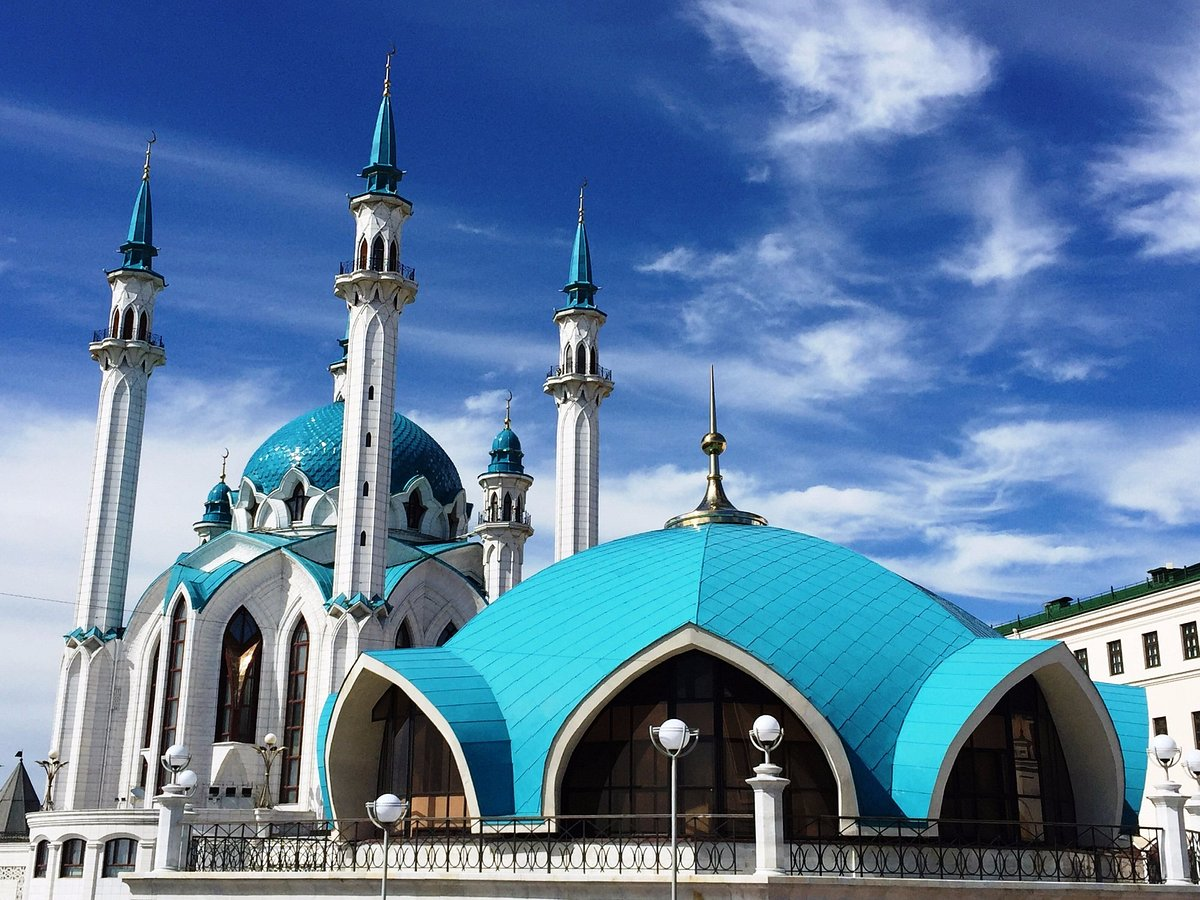Analyze the image in a comprehensive and detailed manner. The image showcases the Qolşärif Mosque located within the Kazan Kremlin, in Kazan, Russia. This mosque, characterized by its vibrant blue and white facade, features four slender minarets and a large central dome, reflecting the Tatar architectural style. The mosque is not only a religious site but also a symbol of Tatar national pride and cultural identity. Its reconstruction was completed in 2005, originally being built in the 16th century but destroyed during the Siege of Kazan. The clear blue sky and fluffy clouds above add a serene atmosphere to the scene, enhancing the visual appeal of the mosque. 